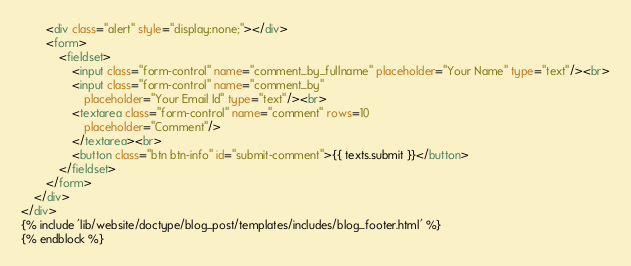Convert code to text. <code><loc_0><loc_0><loc_500><loc_500><_HTML_>		<div class="alert" style="display:none;"></div>
		<form>
			<fieldset>
				<input class="form-control" name="comment_by_fullname" placeholder="Your Name" type="text"/><br>
				<input class="form-control" name="comment_by" 
					placeholder="Your Email Id" type="text"/><br>
				<textarea class="form-control" name="comment" rows=10
					placeholder="Comment"/>
				</textarea><br>
				<button class="btn btn-info" id="submit-comment">{{ texts.submit }}</button>
			</fieldset>
		</form>
	</div>
</div>
{% include 'lib/website/doctype/blog_post/templates/includes/blog_footer.html' %}
{% endblock %}</code> 